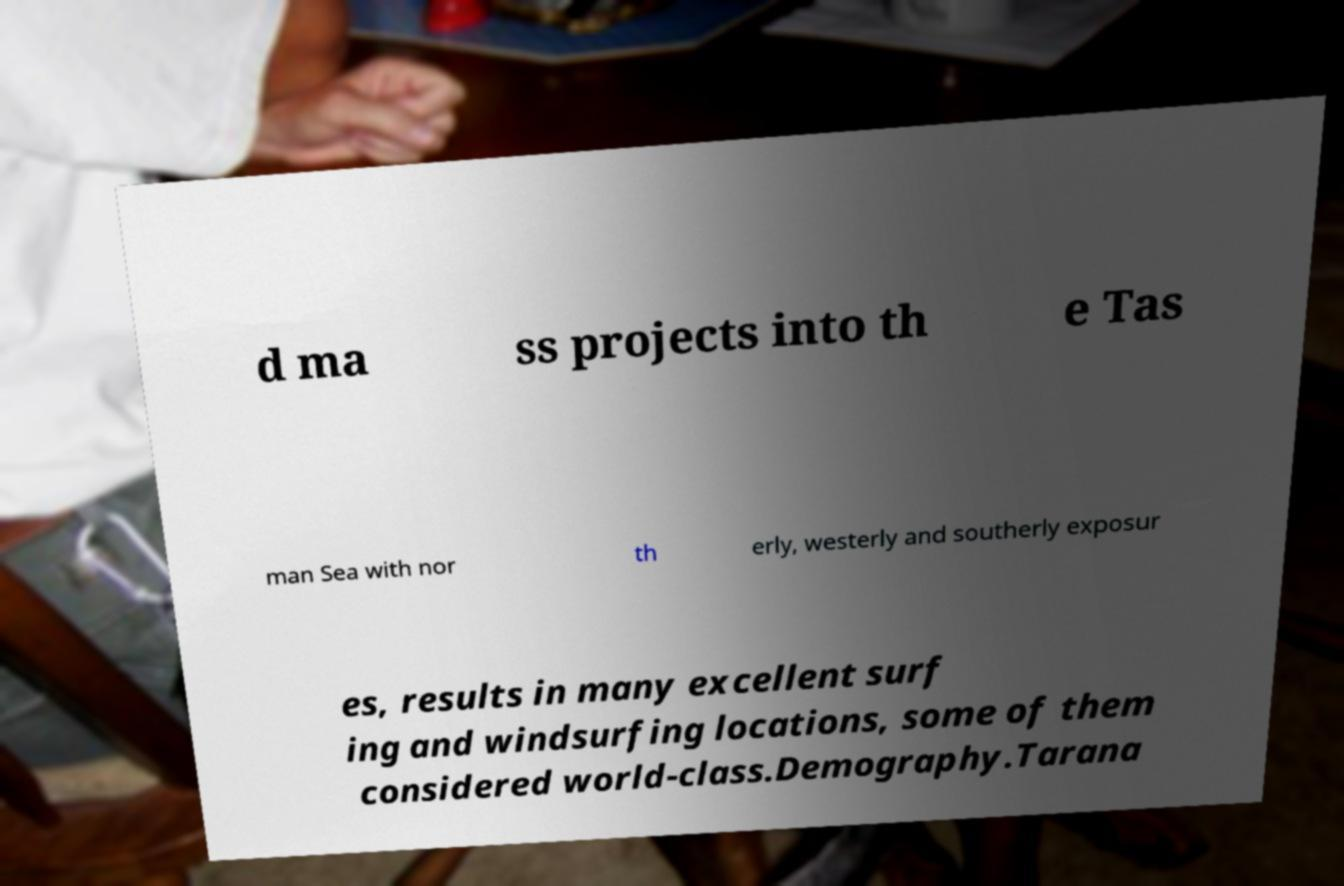Can you read and provide the text displayed in the image?This photo seems to have some interesting text. Can you extract and type it out for me? d ma ss projects into th e Tas man Sea with nor th erly, westerly and southerly exposur es, results in many excellent surf ing and windsurfing locations, some of them considered world-class.Demography.Tarana 